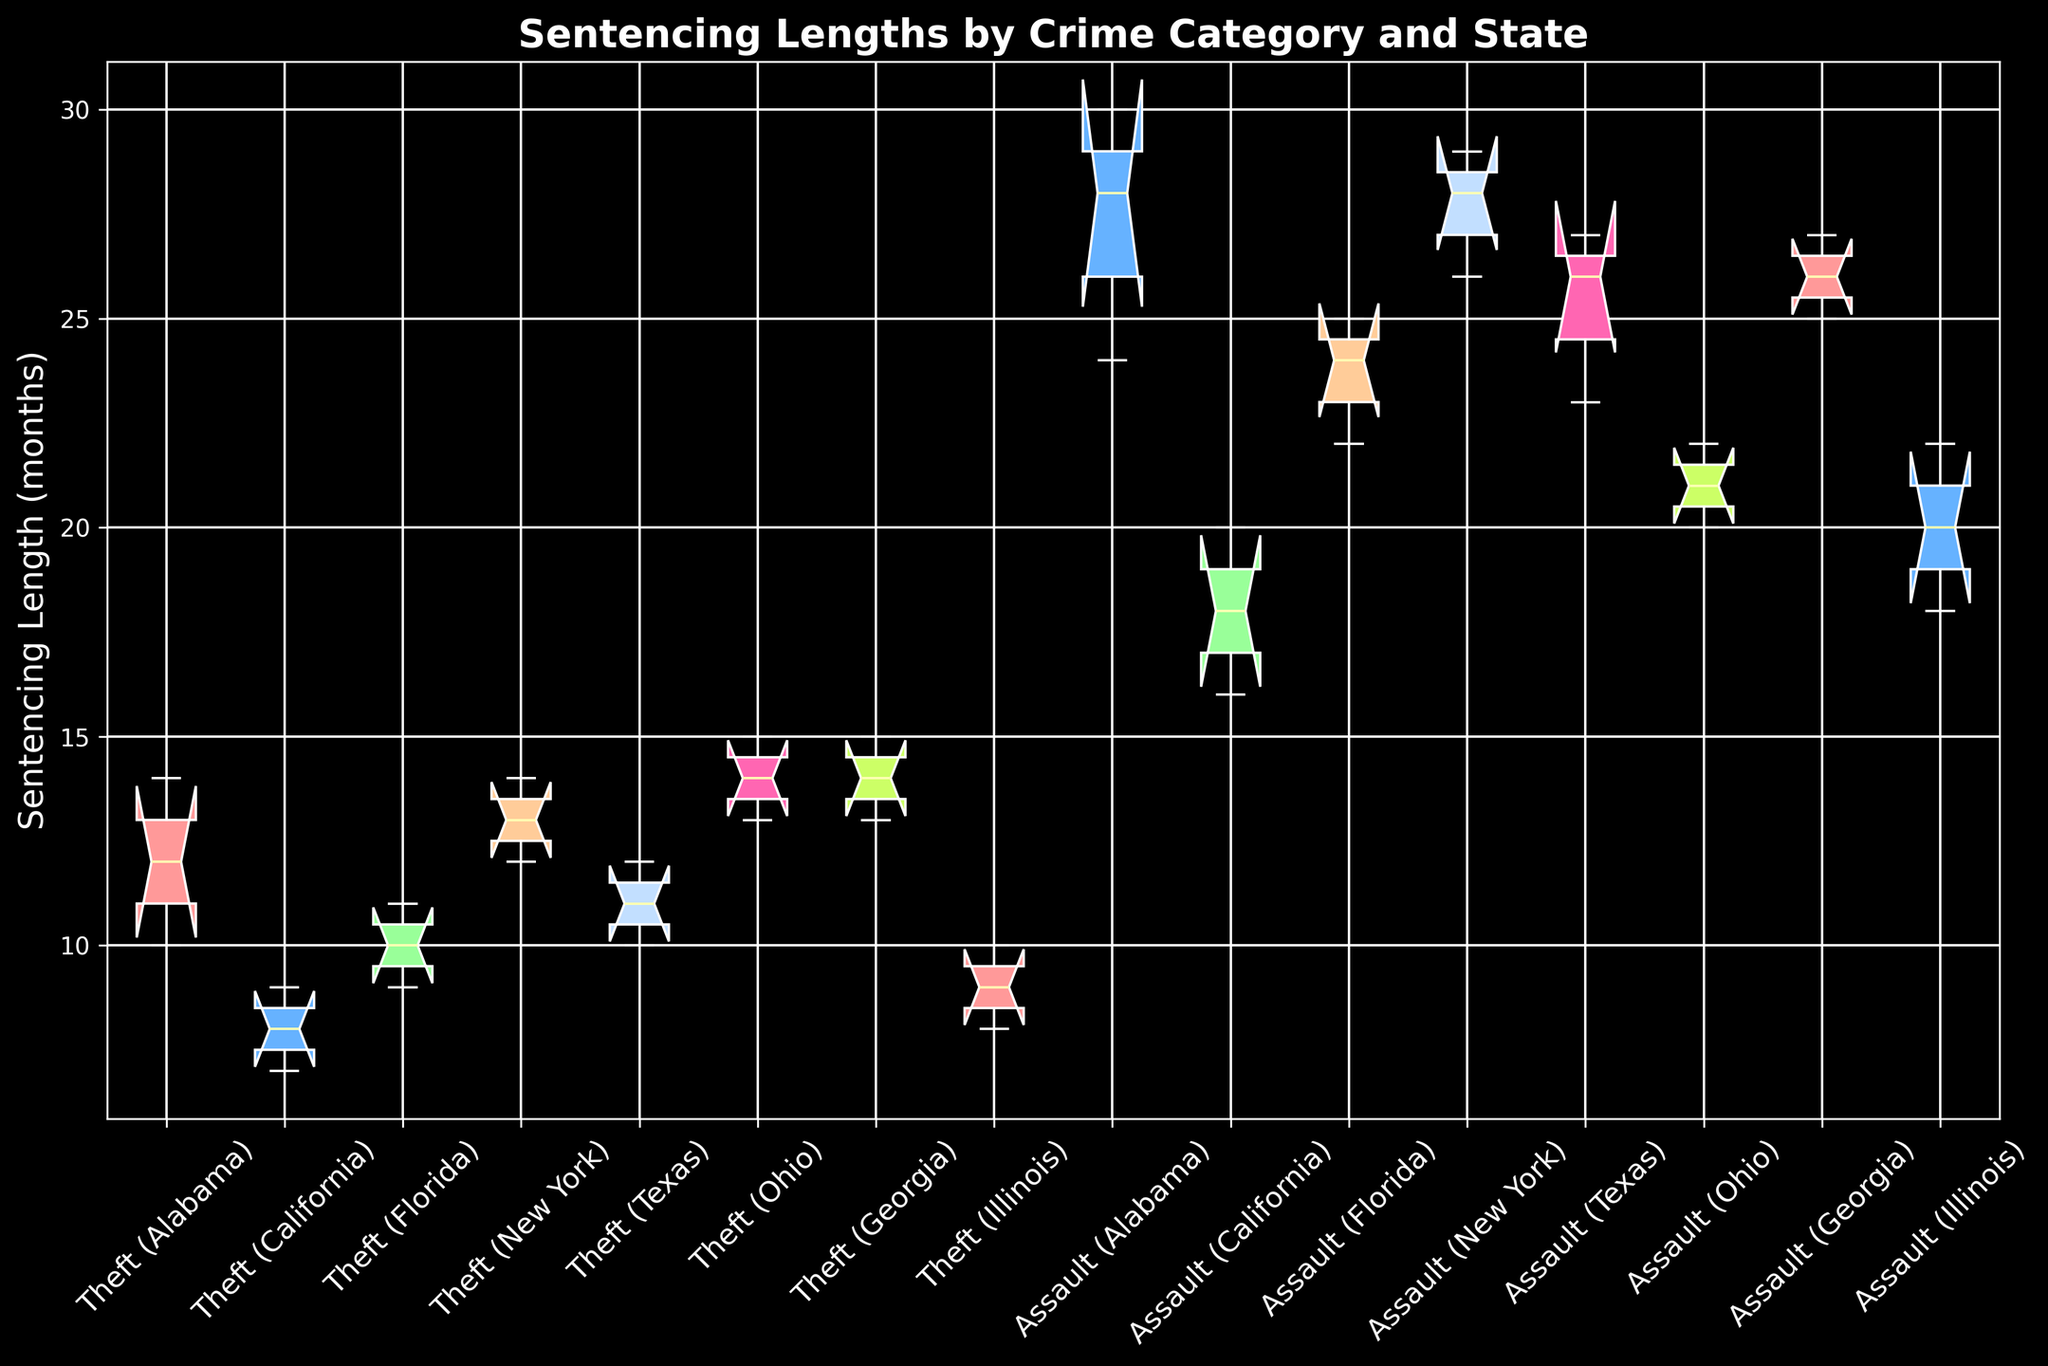Which state has the highest median sentencing length for theft? To find this, look at the median lines inside the boxes related to theft across all states. Identify the highest median among them.
Answer: Georgia Which crime category in Texas has the larger range in sentencing lengths? Compare the length of the boxes (which represent the interquartile range from the 1st quartile to the 3rd quartile) and the whiskers for both theft and assault in Texas.
Answer: Assault What is the median sentencing length for assault in New York? Locate the box that represents assault in New York and identify the line inside the box which represents the median.
Answer: 28 months For the crime category of theft, which state has the smallest interquartile range (IQR)? Look at the length of the boxes representing theft across all states. The smallest box length indicates the smallest IQR.
Answer: California Compare the median sentencing lengths for assault between Alabama and Ohio. Which state has the longer median sentencing length? Locate the boxes for assault in Alabama and Ohio and compare the medians (middle lines in the boxes).
Answer: Alabama Which state shows the widest spread (range between minimum and maximum) in sentencing lengths for assault? Compare the total length from the bottom whisker to the top whisker representing the range for assault across all states.
Answer: Alabama What is the interquartile range (IQR) for theft in Ohio? The IQR is the length of the box for theft in Ohio, measured from the bottom line of the box (1st quartile) to the top line of the box (3rd quartile).
Answer: 2 months Which state's median sentencing length for theft exceeds 10 months? Identify states by the boxes labeled theft where the median line (inside the box) is above 10 months.
Answer: New York, Ohio, Georgia How does the median sentencing length for theft in Alabama compare to that in Illinois? Compare the position of the median lines within the theft boxes for Alabama and Illinois.
Answer: Alabama has a longer median For assault cases, which state has a median sentencing length close to 20 months? Locate the boxes labeled assault and find the median lines that approximate 20 months.
Answer: California, Ohio 